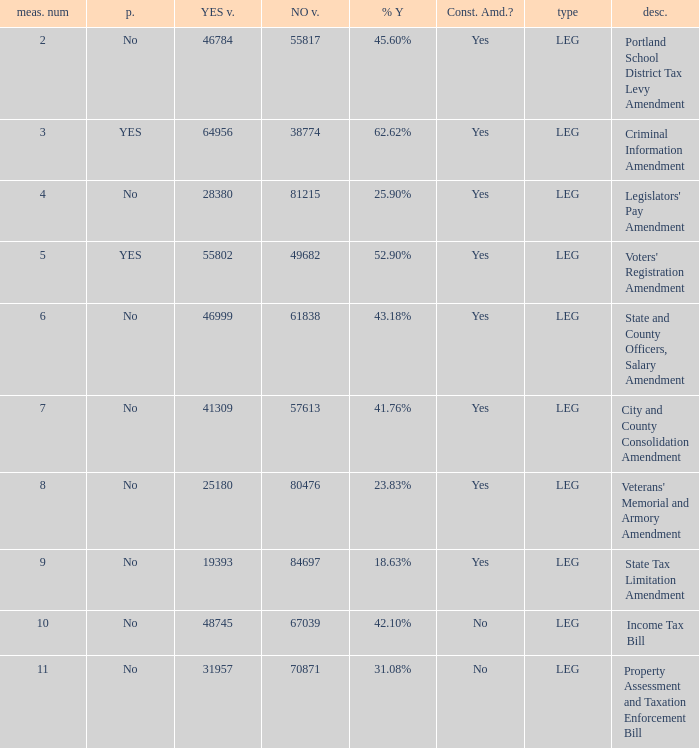How many yes votes made up 43.18% yes? 46999.0. 